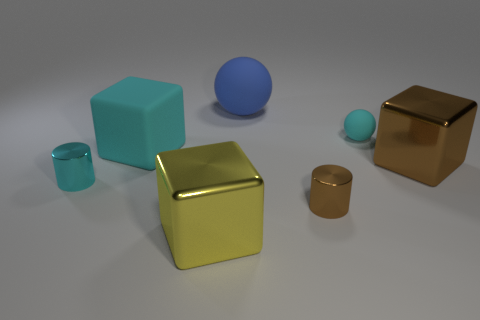Are there more large yellow metallic blocks that are right of the tiny brown thing than large blue things?
Your response must be concise. No. The big brown object that is made of the same material as the big yellow block is what shape?
Your response must be concise. Cube. There is a metal cube behind the large metallic object left of the small brown metal cylinder; what is its color?
Offer a very short reply. Brown. Is the large cyan rubber thing the same shape as the yellow object?
Your answer should be compact. Yes. What material is the other object that is the same shape as the large blue thing?
Ensure brevity in your answer.  Rubber. Are there any large brown shiny blocks behind the cube that is to the right of the shiny cylinder that is to the right of the big yellow metallic thing?
Make the answer very short. No. Do the yellow metallic object and the tiny object on the left side of the large blue matte sphere have the same shape?
Provide a succinct answer. No. Is there any other thing that is the same color as the big rubber ball?
Give a very brief answer. No. There is a small metal thing that is to the left of the big cyan thing; is it the same color as the sphere behind the small cyan matte ball?
Your response must be concise. No. Are there any yellow cubes?
Offer a terse response. Yes. 